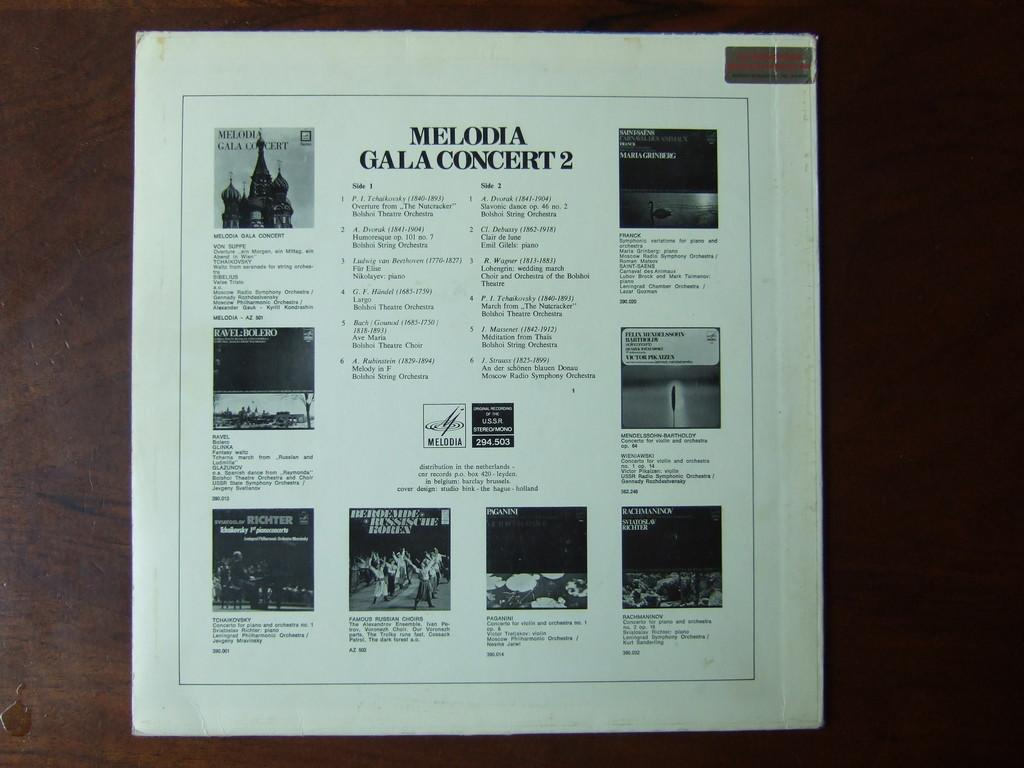<image>
Share a concise interpretation of the image provided. A show program from Melodia Gala Concert 2 with a castle at the top 